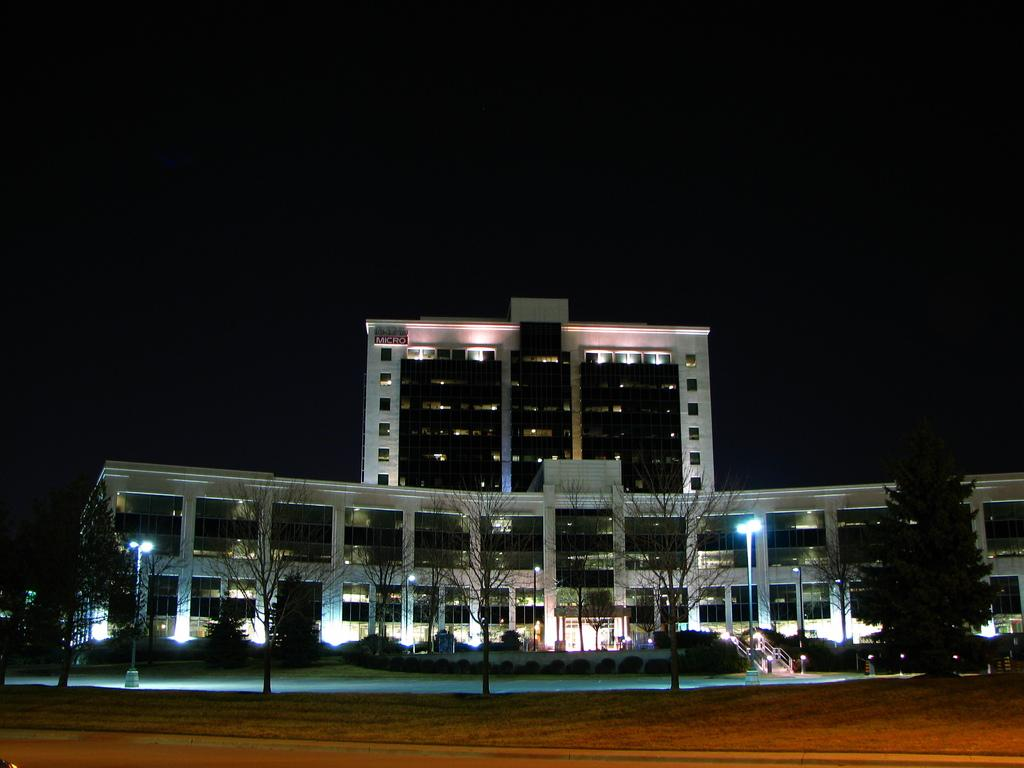What type of natural elements can be seen in the image? There are trees in the image. What type of artificial elements can be seen in the image? There are lights, a road, street lights, and a building in the image. What is visible in the sky in the image? The sky is visible in the image. What type of wool can be seen on the chair in the image? There is no wool or chair present in the image. How many wheels can be seen on the objects in the image? There are no wheels visible in the image. 